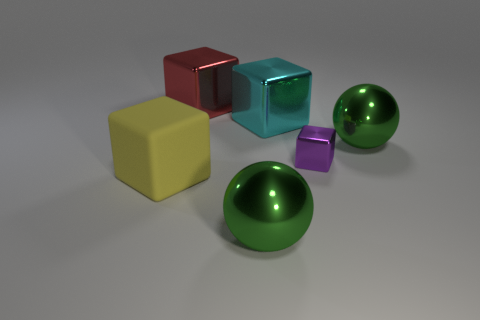Does the large matte cube have the same color as the sphere that is behind the large yellow matte object?
Keep it short and to the point. No. Is the number of big yellow cubes on the right side of the tiny metallic cube greater than the number of big rubber cubes?
Your answer should be compact. No. How many objects are either large metallic spheres that are in front of the yellow rubber thing or large green metallic spheres that are on the left side of the cyan cube?
Your answer should be compact. 1. There is a red block that is the same material as the large cyan cube; what size is it?
Ensure brevity in your answer.  Large. Do the large shiny thing behind the big cyan cube and the cyan object have the same shape?
Offer a terse response. Yes. What number of gray things are cubes or big rubber things?
Make the answer very short. 0. What number of other things are there of the same shape as the large cyan metallic object?
Give a very brief answer. 3. What shape is the large metallic thing that is both in front of the cyan cube and on the left side of the small shiny object?
Provide a short and direct response. Sphere. There is a small purple metallic cube; are there any small purple shiny blocks behind it?
Keep it short and to the point. No. The cyan metallic thing that is the same shape as the large red shiny thing is what size?
Give a very brief answer. Large. 